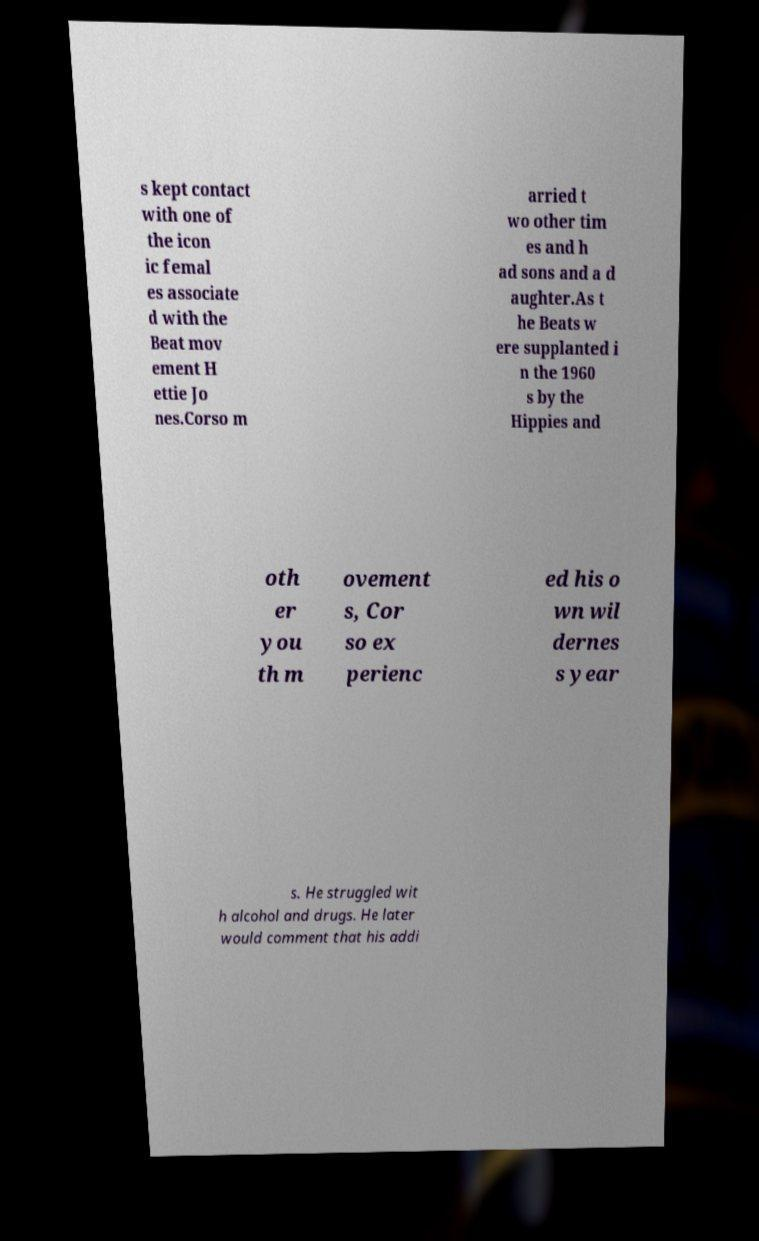Could you assist in decoding the text presented in this image and type it out clearly? s kept contact with one of the icon ic femal es associate d with the Beat mov ement H ettie Jo nes.Corso m arried t wo other tim es and h ad sons and a d aughter.As t he Beats w ere supplanted i n the 1960 s by the Hippies and oth er you th m ovement s, Cor so ex perienc ed his o wn wil dernes s year s. He struggled wit h alcohol and drugs. He later would comment that his addi 